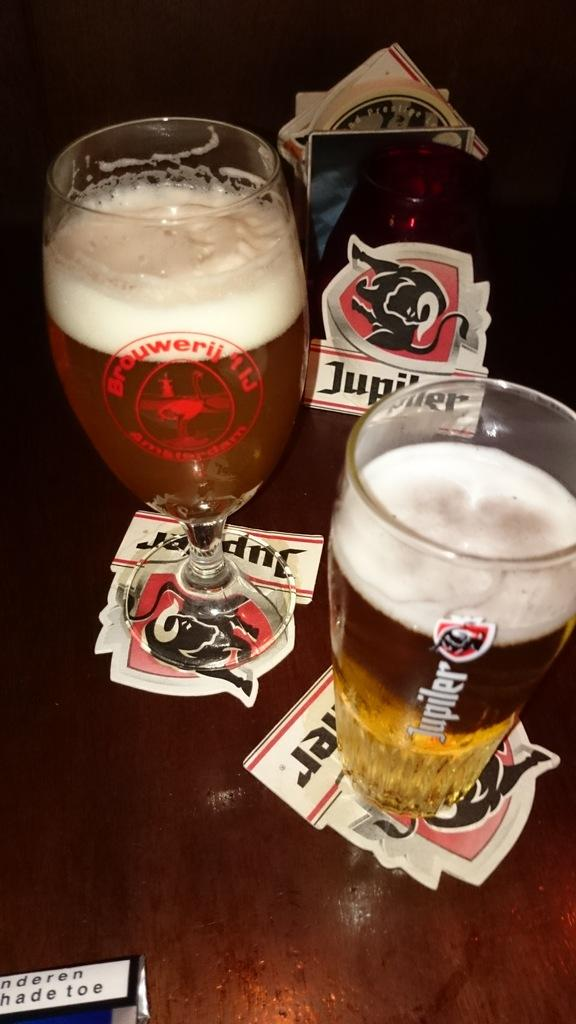<image>
Share a concise interpretation of the image provided. A full glass that says Jupiler on the side on a wooden table. 